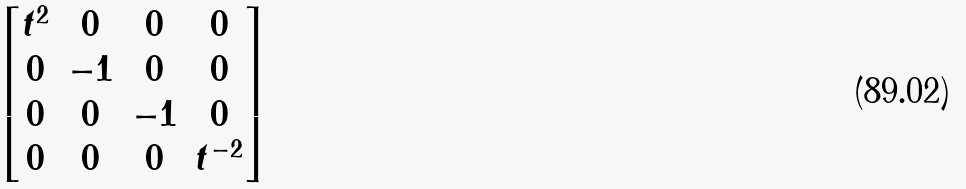<formula> <loc_0><loc_0><loc_500><loc_500>\begin{bmatrix} t ^ { 2 } & 0 & 0 & 0 \\ 0 & - 1 & 0 & 0 \\ 0 & 0 & - 1 & 0 \\ 0 & 0 & 0 & t ^ { - 2 } \end{bmatrix}</formula> 